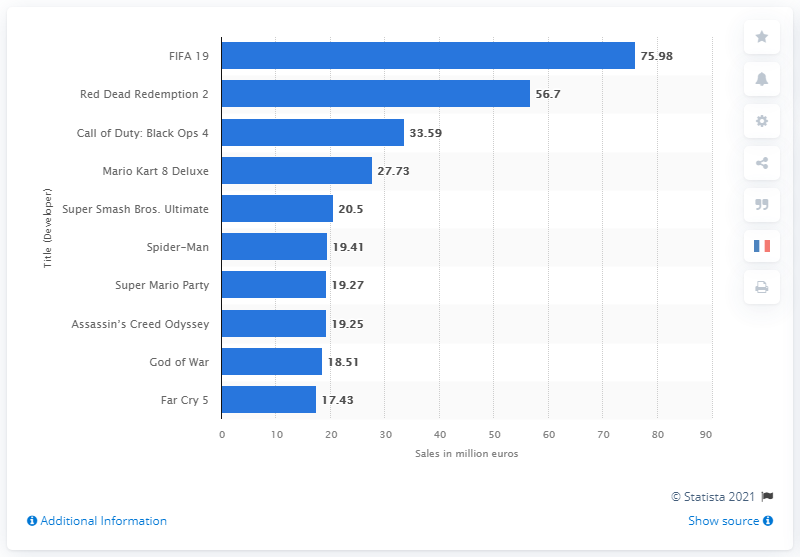Mention a couple of crucial points in this snapshot. The FIFA 19 video game franchise generated almost 76 million euros in sales revenue. The FIFA franchise generates approximately 75.98 million revenue. 